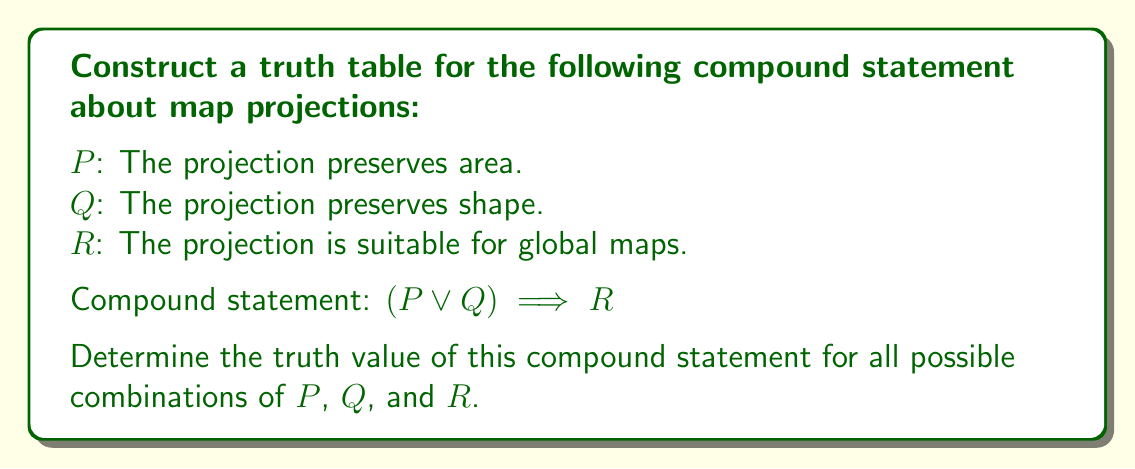Give your solution to this math problem. To construct a truth table for the given compound statement, we need to follow these steps:

1. List all possible combinations of truth values for $P$, $Q$, and $R$.
2. Evaluate the subexpression $P \lor Q$.
3. Evaluate the implication $(P \lor Q) \implies R$.

Step 1: List all combinations
There are 8 possible combinations for three variables:

$$\begin{array}{|c|c|c|}
\hline
P & Q & R \\
\hline
T & T & T \\
T & T & F \\
T & F & T \\
T & F & F \\
F & T & T \\
F & T & F \\
F & F & T \\
F & F & F \\
\hline
\end{array}$$

Step 2: Evaluate $P \lor Q$
The logical OR operation results in true if at least one of the operands is true.

$$\begin{array}{|c|c|c|c|}
\hline
P & Q & R & P \lor Q \\
\hline
T & T & T & T \\
T & T & F & T \\
T & F & T & T \\
T & F & F & T \\
F & T & T & T \\
F & T & F & T \\
F & F & T & F \\
F & F & F & F \\
\hline
\end{array}$$

Step 3: Evaluate $(P \lor Q) \implies R$
The implication is false only when the antecedent is true and the consequent is false.

$$\begin{array}{|c|c|c|c|c|}
\hline
P & Q & R & P \lor Q & (P \lor Q) \implies R \\
\hline
T & T & T & T & T \\
T & T & F & T & F \\
T & F & T & T & T \\
T & F & F & T & F \\
F & T & T & T & T \\
F & T & F & T & F \\
F & F & T & F & T \\
F & F & F & F & T \\
\hline
\end{array}$$

This completes the truth table for the compound statement $(P \lor Q) \implies R$.
Answer: $$\begin{array}{|c|c|c|c|}
\hline
P & Q & R & (P \lor Q) \implies R \\
\hline
T & T & T & T \\
T & T & F & F \\
T & F & T & T \\
T & F & F & F \\
F & T & T & T \\
F & T & F & F \\
F & F & T & T \\
F & F & F & T \\
\hline
\end{array}$$ 